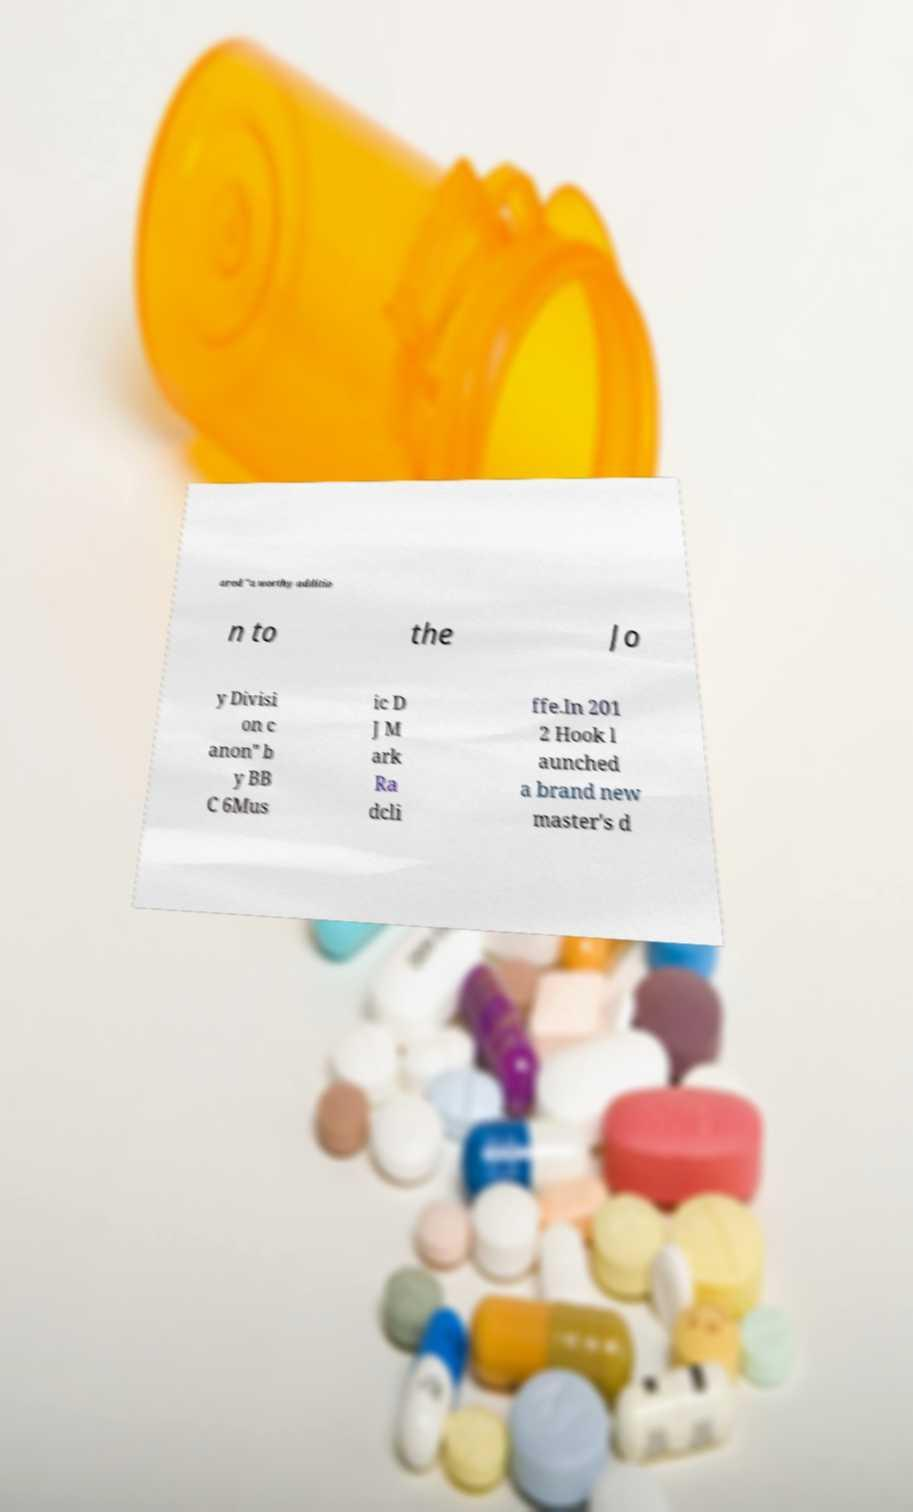Please identify and transcribe the text found in this image. ared "a worthy additio n to the Jo y Divisi on c anon" b y BB C 6Mus ic D J M ark Ra dcli ffe.In 201 2 Hook l aunched a brand new master's d 